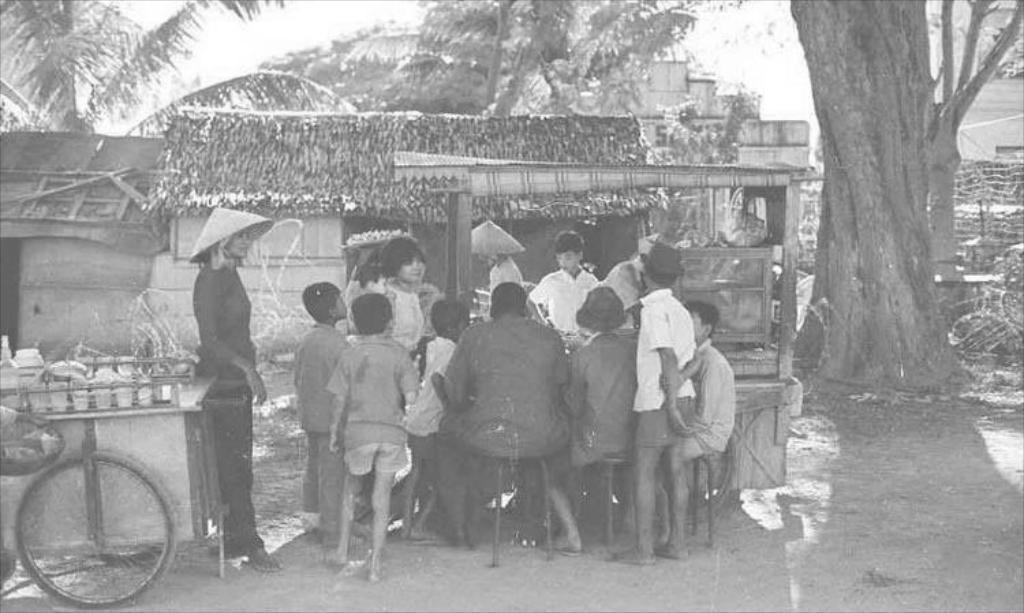Please provide a concise description of this image. In the center of the picture there are group of people around the cart. On the left there is a cart and a person standing. On the right there is a huge tree. In the center of the picture there are houses, trees and other objects. In the background it is sky. 